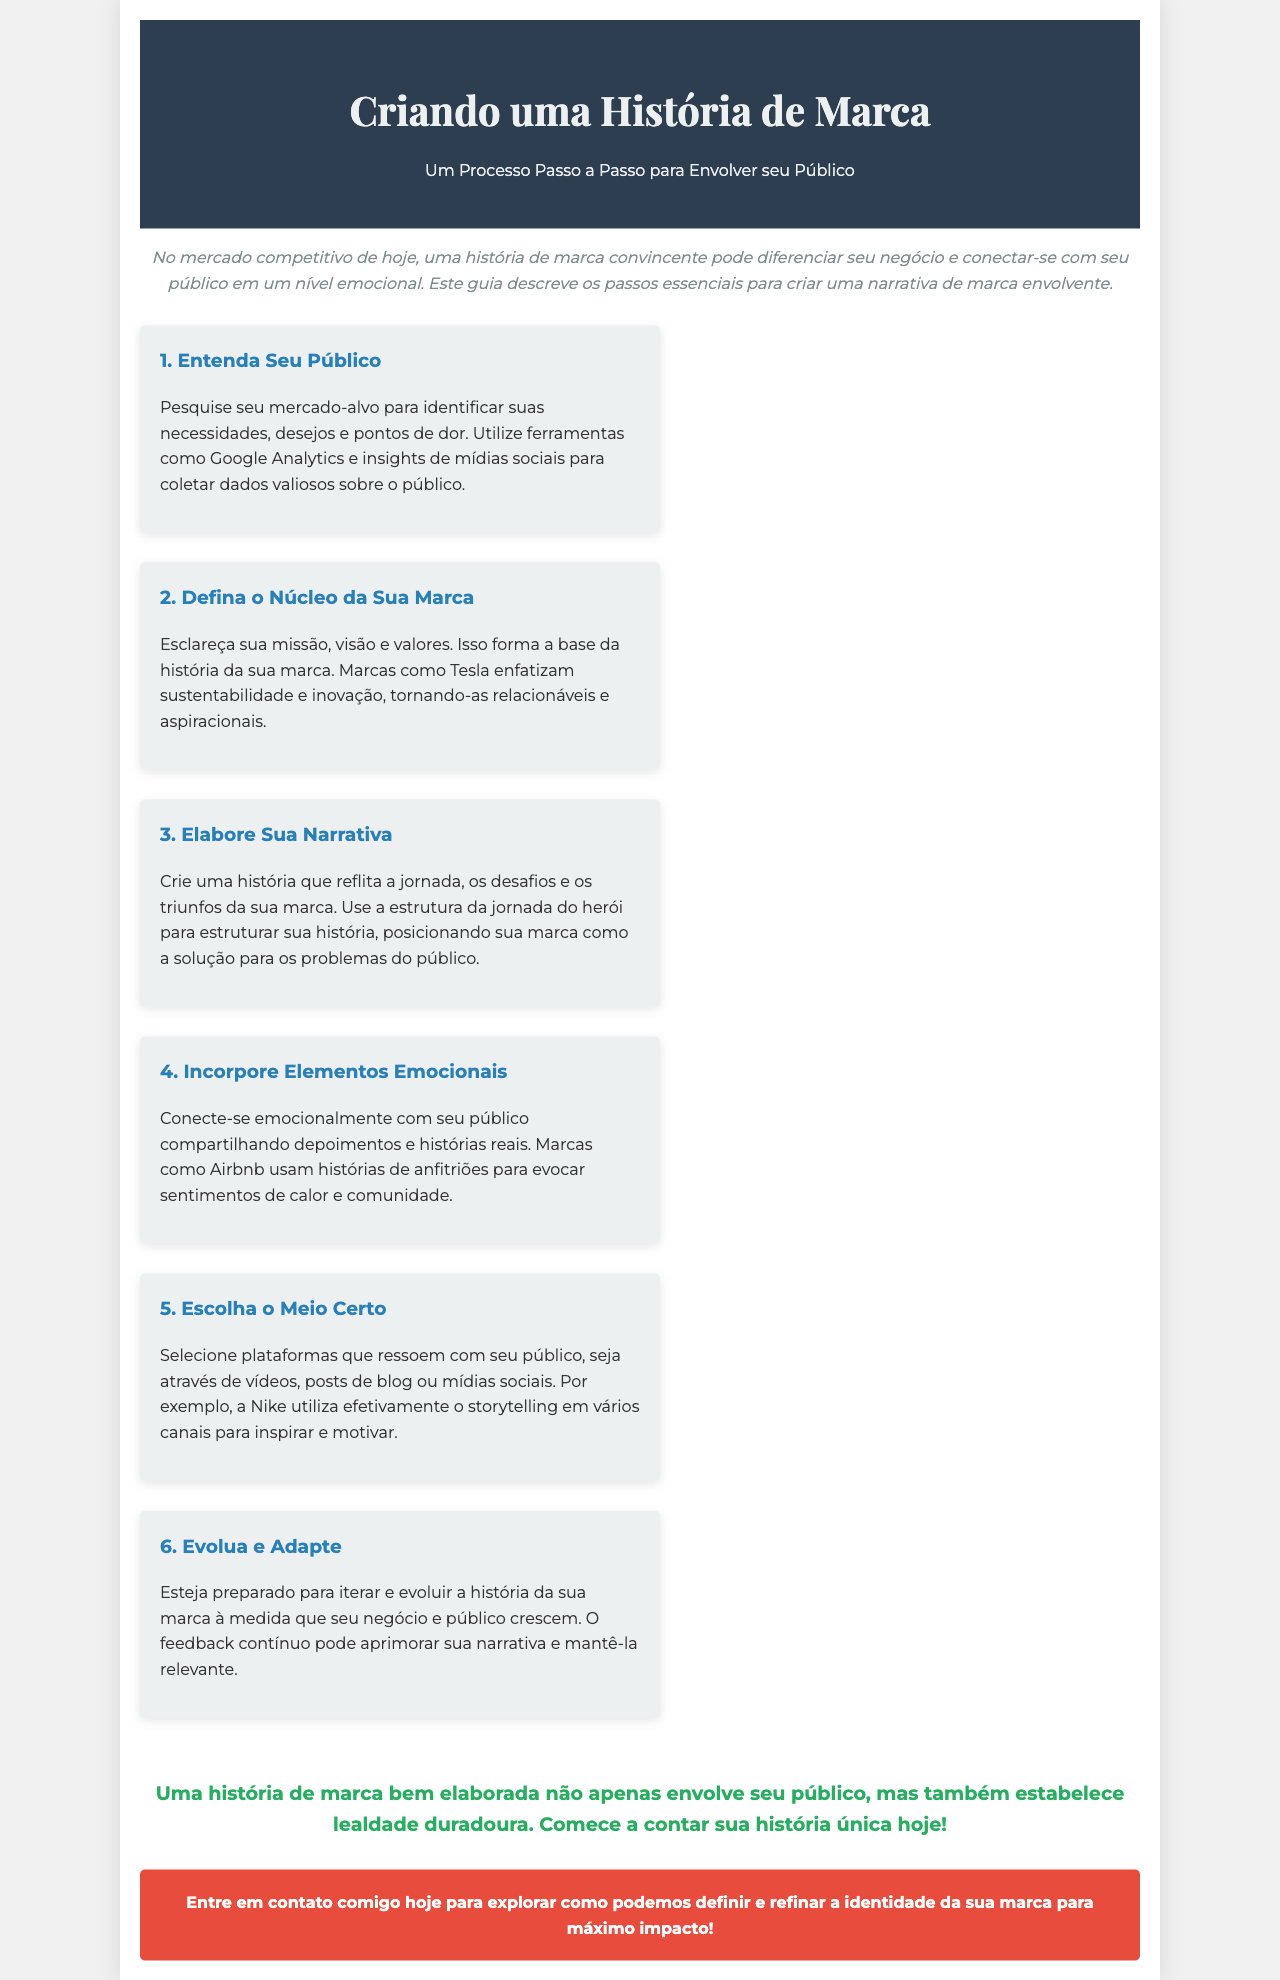qual é o título do documento? O título do documento é exibido na parte superior da brochura.
Answer: Criando uma História de Marca quantos passos são descritos para criar uma narrativa de marca? Os passos são numerados na seção de etapas e a contagem total é indicada no formato de lista.
Answer: 6 quais são as cores do cabeçalho? As cores do cabeçalho são especificadas na parte superior do documento.
Answer: #2c3e50 e #ecf0f1 o que deve ser feito na etapa 2? A etapa 2 fornece detalhes sobre a definição do núcleo da marca.
Answer: Defina o Núcleo da Sua Marca que elemento emocional as marcas como Airbnb usam? A relação emocional é explicada na seção da etapa 4 e um exemplo é fornecido.
Answer: Histórias de anfitriões por que é importante evoluir e adaptar a história da marca? A importância está explicada na última etapa da seção que discute a evolução.
Answer: Para manter a relevância 